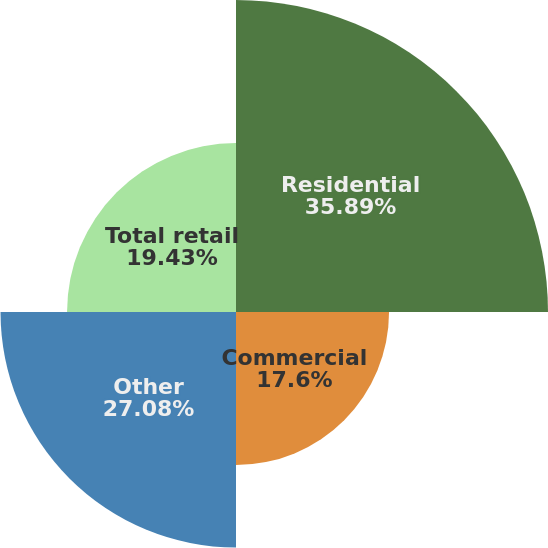Convert chart to OTSL. <chart><loc_0><loc_0><loc_500><loc_500><pie_chart><fcel>Residential<fcel>Commercial<fcel>Other<fcel>Total retail<nl><fcel>35.88%<fcel>17.6%<fcel>27.08%<fcel>19.43%<nl></chart> 